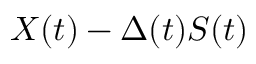<formula> <loc_0><loc_0><loc_500><loc_500>X ( t ) - \Delta ( t ) S ( t )</formula> 